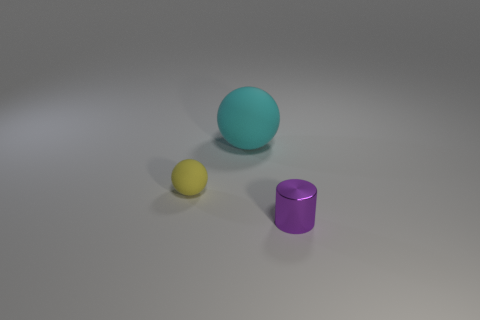How does the color of the large teal sphere compare to the other objects? The large teal sphere's color stands out against the plain background and contrasts with the vibrant yellow of the smaller sphere and the muted purple of the cylinder. Its color gives it a calming presence within the trio of objects. 